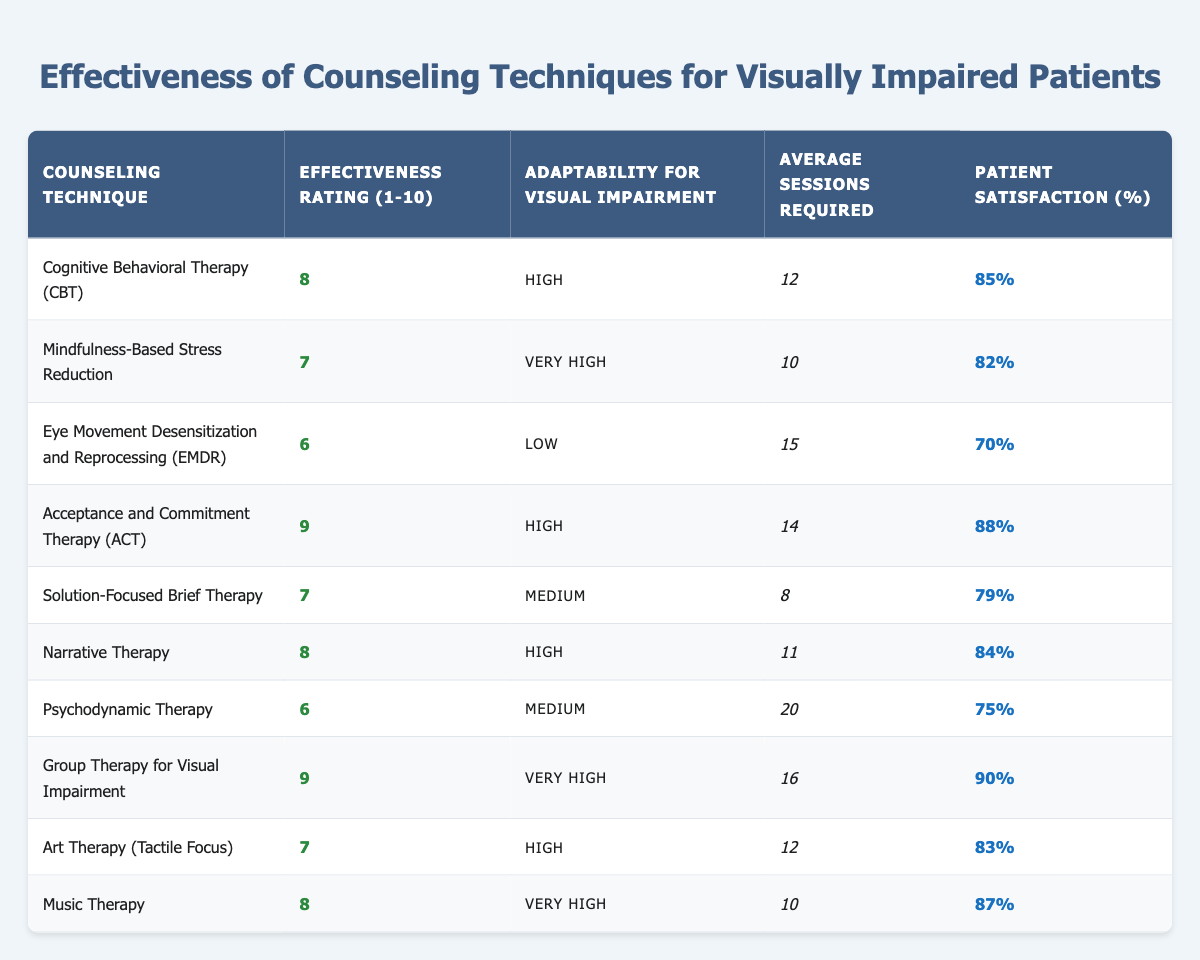What is the effectiveness rating of Cognitive Behavioral Therapy (CBT)? The effectiveness rating for CBT is clearly listed in the table under the "Effectiveness Rating (1-10)" column, which shows a value of 8.
Answer: 8 Which counseling technique has the highest patient satisfaction percentage? By reviewing the "Patient Satisfaction (%)" column, the highest listed value is 90% for "Group Therapy for Visual Impairment".
Answer: Group Therapy for Visual Impairment What is the average number of sessions required for Acceptance and Commitment Therapy (ACT) and Group Therapy for Visual Impairment? The average number of sessions for ACT is 14, and for Group Therapy for Visual Impairment, it is 16. To find the average, add them together: 14 + 16 = 30, then divide by 2, resulting in 30 / 2 = 15.
Answer: 15 Is there any counseling technique with low adaptability for visual impairment? Referring to the "Adaptability for Visual Impairment" column, "Eye Movement Desensitization and Reprocessing (EMDR)" is the only technique marked as "Low."
Answer: Yes Which therapy technique requires the most average sessions? Analyzing the "Average Sessions Required" column, "Psychodynamic Therapy" requires the most sessions, totaling 20.
Answer: Psychodynamic Therapy What is the difference in average sessions required between Cognitive Behavioral Therapy (CBT) and Mindfulness-Based Stress Reduction? CBT requires 12 sessions, and Mindfulness-Based Stress Reduction requires 10 sessions. The difference can be calculated as 12 - 10 = 2.
Answer: 2 What is the effectiveness rating of the least effective therapy listed? The least effective therapy listed is "Eye Movement Desensitization and Reprocessing (EMDR)", with an effectiveness rating of 6 according to the "Effectiveness Rating (1-10)" column.
Answer: 6 How many techniques have a "Very High" adaptability for visual impairment? In the table, the adaptability ratings include "Very High" for three techniques—"Mindfulness-Based Stress Reduction," "Group Therapy for Visual Impairment," and "Music Therapy." Therefore, there are 3 techniques.
Answer: 3 What is the average patient satisfaction percentage across all counseling techniques? The patient satisfaction percentages are 85, 82, 70, 88, 79, 84, 75, 90, 83, and 87. Adding these gives 838, and dividing by 10 (the number of techniques) provides an average of 83.8.
Answer: 83.8 